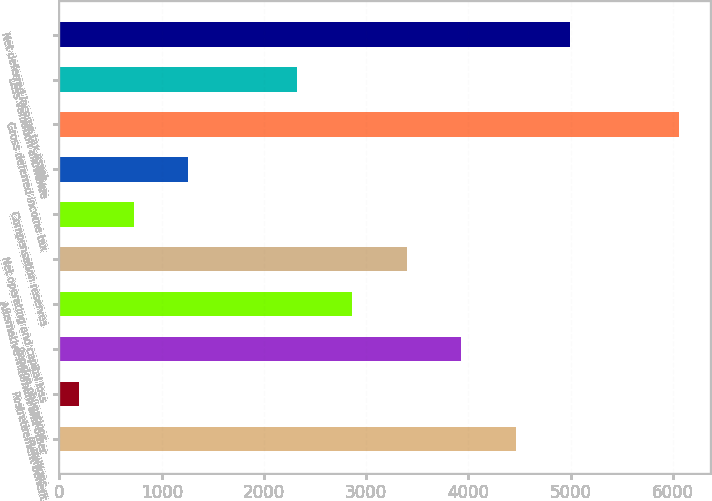<chart> <loc_0><loc_0><loc_500><loc_500><bar_chart><fcel>In millions<fcel>Postretirement benefit<fcel>Pension obligations<fcel>Alternative minimum and other<fcel>Net operating and capital loss<fcel>Compensation reserves<fcel>Other<fcel>Gross deferred income tax<fcel>Less valuation allowance<fcel>Net deferred income tax asset<nl><fcel>4462.6<fcel>193<fcel>3928.9<fcel>2861.5<fcel>3395.2<fcel>726.7<fcel>1260.4<fcel>6063.7<fcel>2327.8<fcel>4996.3<nl></chart> 